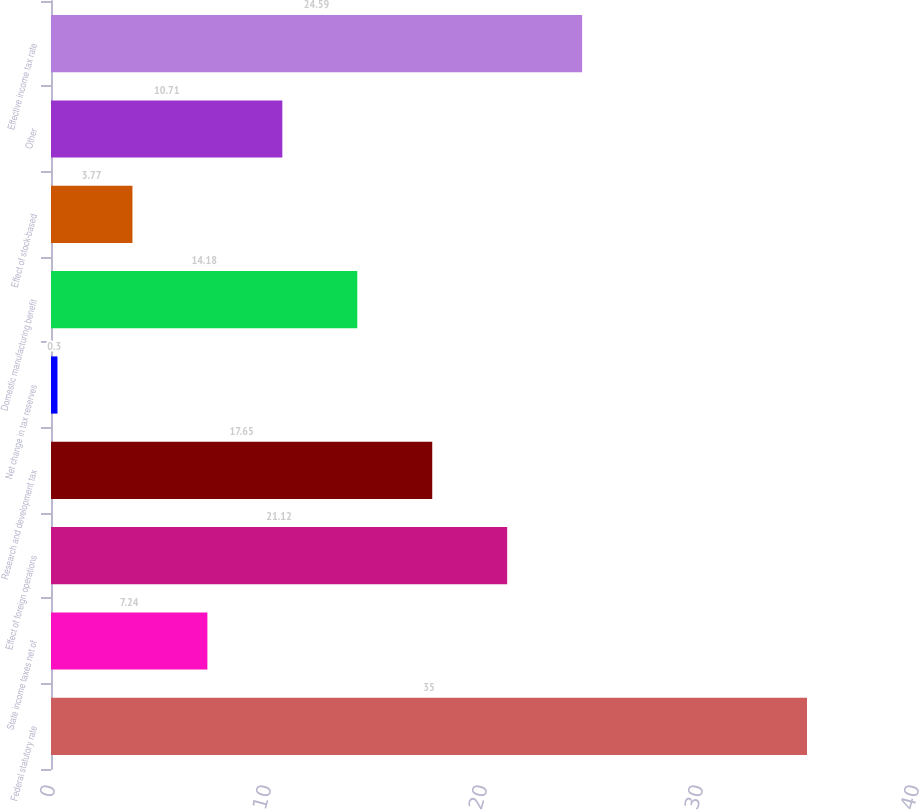Convert chart. <chart><loc_0><loc_0><loc_500><loc_500><bar_chart><fcel>Federal statutory rate<fcel>State income taxes net of<fcel>Effect of foreign operations<fcel>Research and development tax<fcel>Net change in tax reserves<fcel>Domestic manufacturing benefit<fcel>Effect of stock-based<fcel>Other<fcel>Effective income tax rate<nl><fcel>35<fcel>7.24<fcel>21.12<fcel>17.65<fcel>0.3<fcel>14.18<fcel>3.77<fcel>10.71<fcel>24.59<nl></chart> 